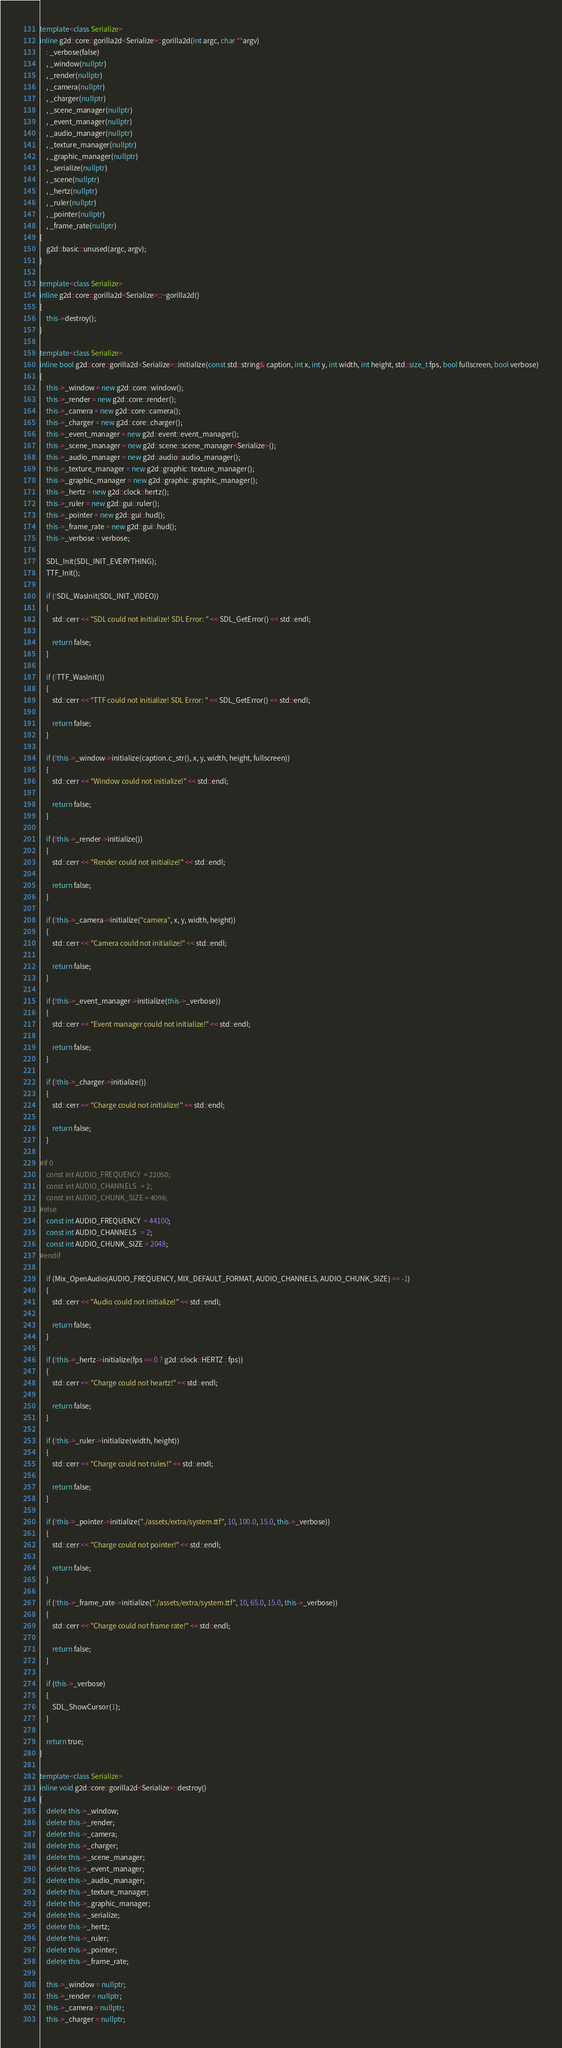Convert code to text. <code><loc_0><loc_0><loc_500><loc_500><_C++_>template<class Serialize>
inline g2d::core::gorilla2d<Serialize>::gorilla2d(int argc, char **argv)
	: _verbose(false)
	, _window(nullptr)
	, _render(nullptr)
	, _camera(nullptr)
	, _charger(nullptr)
	, _scene_manager(nullptr)
	, _event_manager(nullptr)
	, _audio_manager(nullptr)
	, _texture_manager(nullptr)
	, _graphic_manager(nullptr)
	, _serialize(nullptr)
	, _scene(nullptr)
	, _hertz(nullptr)
	, _ruler(nullptr)
	, _pointer(nullptr)
	, _frame_rate(nullptr)
{
	g2d::basic::unused(argc, argv);
}

template<class Serialize>
inline g2d::core::gorilla2d<Serialize>::~gorilla2d()
{
	this->destroy();
}

template<class Serialize>
inline bool g2d::core::gorilla2d<Serialize>::initialize(const std::string& caption, int x, int y, int width, int height, std::size_t fps, bool fullscreen, bool verbose)
{
	this->_window = new g2d::core::window();
	this->_render = new g2d::core::render();
	this->_camera = new g2d::core::camera();
	this->_charger = new g2d::core::charger();
	this->_event_manager = new g2d::event::event_manager();
	this->_scene_manager = new g2d::scene::scene_manager<Serialize>();
	this->_audio_manager = new g2d::audio::audio_manager();
	this->_texture_manager = new g2d::graphic::texture_manager();
	this->_graphic_manager = new g2d::graphic::graphic_manager();
	this->_hertz = new g2d::clock::hertz();
	this->_ruler = new g2d::gui::ruler();
	this->_pointer = new g2d::gui::hud();
	this->_frame_rate = new g2d::gui::hud();
	this->_verbose = verbose;

	SDL_Init(SDL_INIT_EVERYTHING);
	TTF_Init();

	if (!SDL_WasInit(SDL_INIT_VIDEO))
	{
		std::cerr << "SDL could not initialize! SDL Error: " << SDL_GetError() << std::endl;

		return false;
	}

	if (!TTF_WasInit())
	{
		std::cerr << "TTF could not initialize! SDL Error: " << SDL_GetError() << std::endl;

		return false;
	}

	if (!this->_window->initialize(caption.c_str(), x, y, width, height, fullscreen))
	{
		std::cerr << "Window could not initialize!" << std::endl;

		return false;
	}

	if (!this->_render->initialize())
	{
		std::cerr << "Render could not initialize!" << std::endl;

		return false;
	}

	if (!this->_camera->initialize("camera", x, y, width, height))
	{
		std::cerr << "Camera could not initialize!" << std::endl;

		return false;
	}

	if (!this->_event_manager->initialize(this->_verbose))
	{
		std::cerr << "Event manager could not initialize!" << std::endl;

		return false;
	}

	if (!this->_charger->initialize())
	{
		std::cerr << "Charge could not initialize!" << std::endl;

		return false;
	}

#if 0
	const int AUDIO_FREQUENCY  = 22050;
	const int AUDIO_CHANNELS   = 2;
	const int AUDIO_CHUNK_SIZE = 4096;
#else
	const int AUDIO_FREQUENCY  = 44100;
	const int AUDIO_CHANNELS   = 2;
	const int AUDIO_CHUNK_SIZE = 2048;
#endif

	if (Mix_OpenAudio(AUDIO_FREQUENCY, MIX_DEFAULT_FORMAT, AUDIO_CHANNELS, AUDIO_CHUNK_SIZE) == -1)
	{
		std::cerr << "Audio could not initialize!" << std::endl;

		return false;
	}

	if (!this->_hertz->initialize(fps == 0 ? g2d::clock::HERTZ : fps))
	{
		std::cerr << "Charge could not heartz!" << std::endl;

		return false;
	}

	if (!this->_ruler->initialize(width, height))
	{
		std::cerr << "Charge could not rules!" << std::endl;

		return false;
	}

	if (!this->_pointer->initialize("./assets/extra/system.ttf", 10, 100.0, 15.0, this->_verbose))
	{
		std::cerr << "Charge could not pointer!" << std::endl;

		return false;
	}

	if (!this->_frame_rate->initialize("./assets/extra/system.ttf", 10, 65.0, 15.0, this->_verbose))
	{
		std::cerr << "Charge could not frame rate!" << std::endl;

		return false;
	}

	if (this->_verbose)
	{
		SDL_ShowCursor(1);
	}

	return true;
}

template<class Serialize>
inline void g2d::core::gorilla2d<Serialize>::destroy()
{
	delete this->_window;
	delete this->_render;
	delete this->_camera;
	delete this->_charger;
	delete this->_scene_manager;
	delete this->_event_manager;
	delete this->_audio_manager;
	delete this->_texture_manager;
	delete this->_graphic_manager;
	delete this->_serialize;
	delete this->_hertz;
	delete this->_ruler;
	delete this->_pointer;
	delete this->_frame_rate;

	this->_window = nullptr;
	this->_render = nullptr;
	this->_camera = nullptr;
	this->_charger = nullptr;</code> 